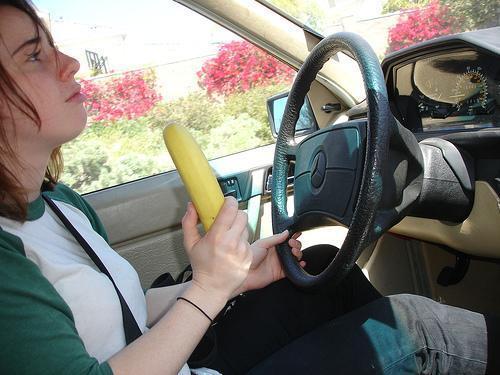How many people are in the photo?
Give a very brief answer. 1. 